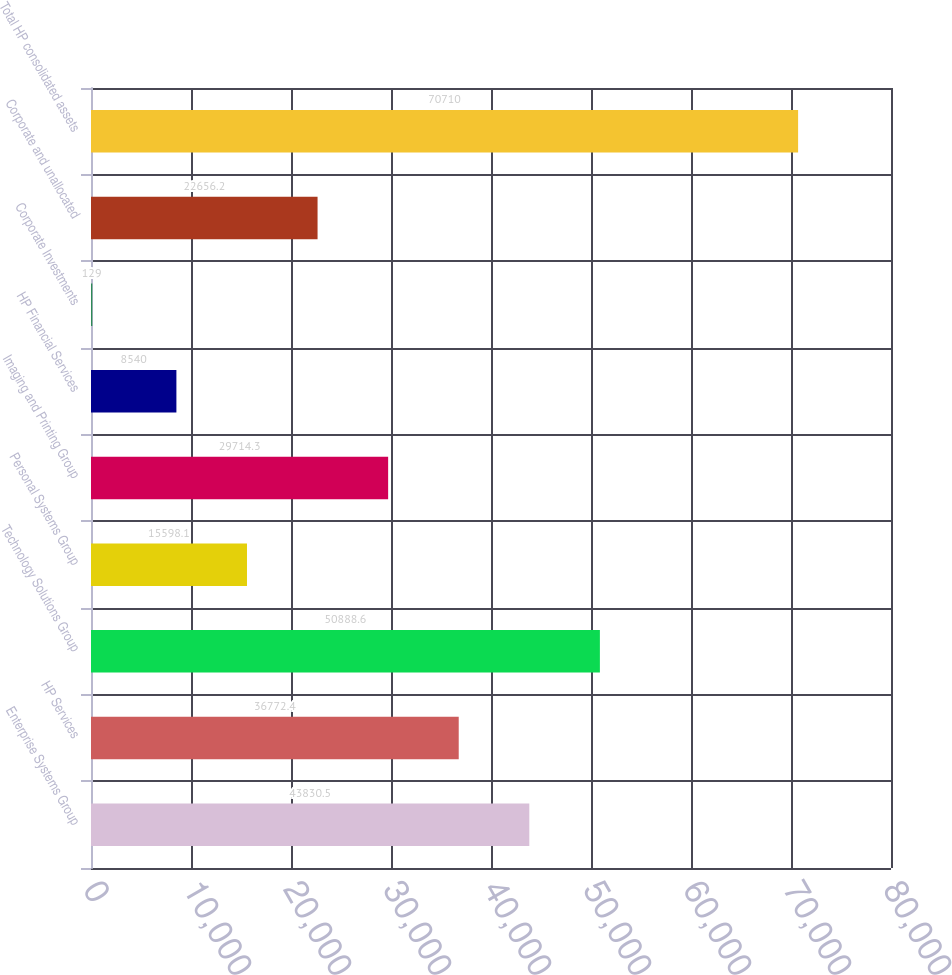Convert chart. <chart><loc_0><loc_0><loc_500><loc_500><bar_chart><fcel>Enterprise Systems Group<fcel>HP Services<fcel>Technology Solutions Group<fcel>Personal Systems Group<fcel>Imaging and Printing Group<fcel>HP Financial Services<fcel>Corporate Investments<fcel>Corporate and unallocated<fcel>Total HP consolidated assets<nl><fcel>43830.5<fcel>36772.4<fcel>50888.6<fcel>15598.1<fcel>29714.3<fcel>8540<fcel>129<fcel>22656.2<fcel>70710<nl></chart> 